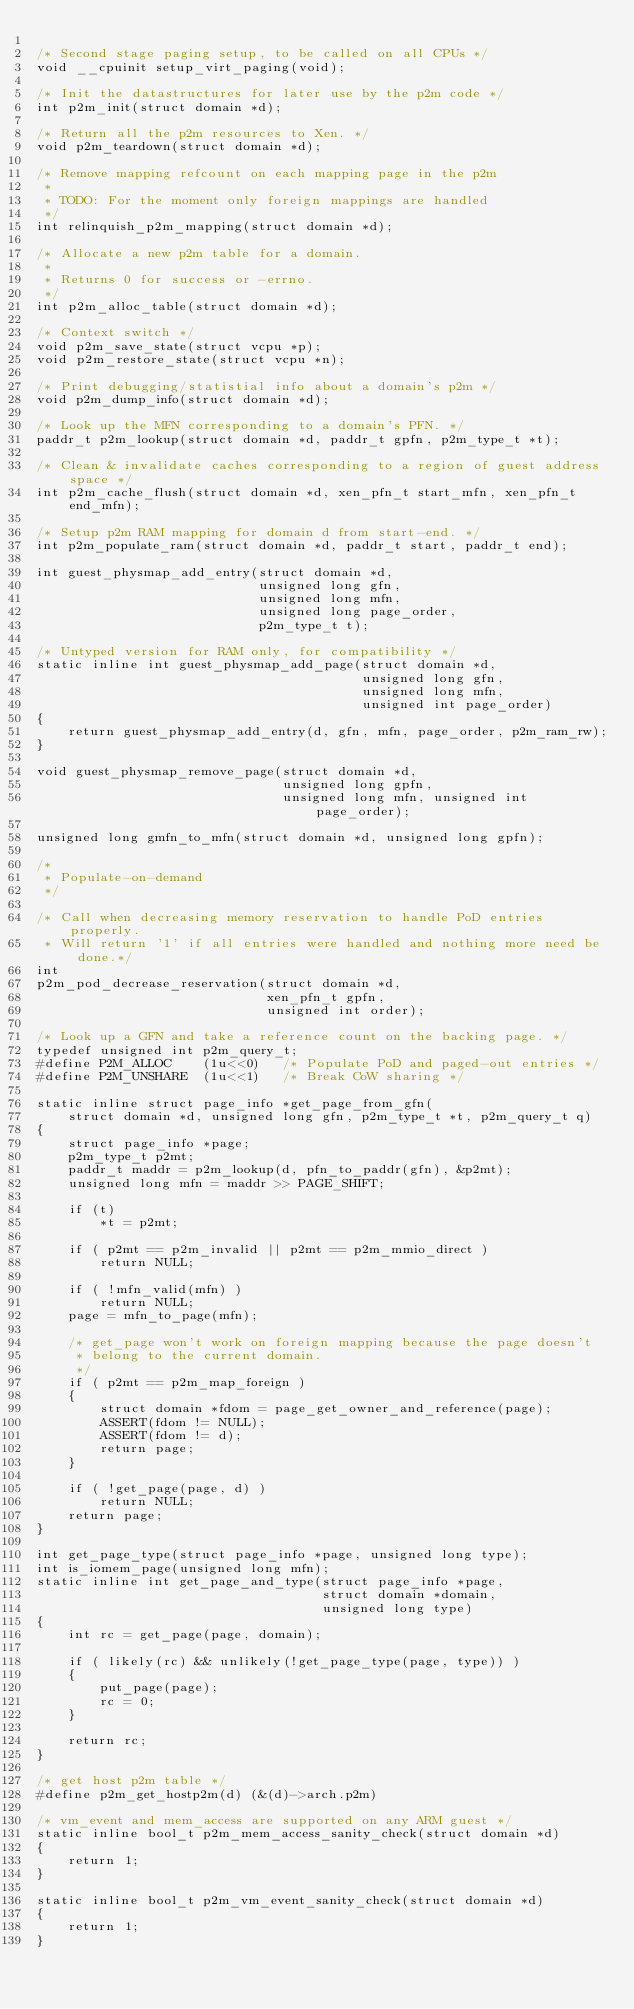<code> <loc_0><loc_0><loc_500><loc_500><_C_>
/* Second stage paging setup, to be called on all CPUs */
void __cpuinit setup_virt_paging(void);

/* Init the datastructures for later use by the p2m code */
int p2m_init(struct domain *d);

/* Return all the p2m resources to Xen. */
void p2m_teardown(struct domain *d);

/* Remove mapping refcount on each mapping page in the p2m
 *
 * TODO: For the moment only foreign mappings are handled
 */
int relinquish_p2m_mapping(struct domain *d);

/* Allocate a new p2m table for a domain.
 *
 * Returns 0 for success or -errno.
 */
int p2m_alloc_table(struct domain *d);

/* Context switch */
void p2m_save_state(struct vcpu *p);
void p2m_restore_state(struct vcpu *n);

/* Print debugging/statistial info about a domain's p2m */
void p2m_dump_info(struct domain *d);

/* Look up the MFN corresponding to a domain's PFN. */
paddr_t p2m_lookup(struct domain *d, paddr_t gpfn, p2m_type_t *t);

/* Clean & invalidate caches corresponding to a region of guest address space */
int p2m_cache_flush(struct domain *d, xen_pfn_t start_mfn, xen_pfn_t end_mfn);

/* Setup p2m RAM mapping for domain d from start-end. */
int p2m_populate_ram(struct domain *d, paddr_t start, paddr_t end);

int guest_physmap_add_entry(struct domain *d,
                            unsigned long gfn,
                            unsigned long mfn,
                            unsigned long page_order,
                            p2m_type_t t);

/* Untyped version for RAM only, for compatibility */
static inline int guest_physmap_add_page(struct domain *d,
                                         unsigned long gfn,
                                         unsigned long mfn,
                                         unsigned int page_order)
{
    return guest_physmap_add_entry(d, gfn, mfn, page_order, p2m_ram_rw);
}

void guest_physmap_remove_page(struct domain *d,
                               unsigned long gpfn,
                               unsigned long mfn, unsigned int page_order);

unsigned long gmfn_to_mfn(struct domain *d, unsigned long gpfn);

/*
 * Populate-on-demand
 */

/* Call when decreasing memory reservation to handle PoD entries properly.
 * Will return '1' if all entries were handled and nothing more need be done.*/
int
p2m_pod_decrease_reservation(struct domain *d,
                             xen_pfn_t gpfn,
                             unsigned int order);

/* Look up a GFN and take a reference count on the backing page. */
typedef unsigned int p2m_query_t;
#define P2M_ALLOC    (1u<<0)   /* Populate PoD and paged-out entries */
#define P2M_UNSHARE  (1u<<1)   /* Break CoW sharing */

static inline struct page_info *get_page_from_gfn(
    struct domain *d, unsigned long gfn, p2m_type_t *t, p2m_query_t q)
{
    struct page_info *page;
    p2m_type_t p2mt;
    paddr_t maddr = p2m_lookup(d, pfn_to_paddr(gfn), &p2mt);
    unsigned long mfn = maddr >> PAGE_SHIFT;

    if (t)
        *t = p2mt;

    if ( p2mt == p2m_invalid || p2mt == p2m_mmio_direct )
        return NULL;

    if ( !mfn_valid(mfn) )
        return NULL;
    page = mfn_to_page(mfn);

    /* get_page won't work on foreign mapping because the page doesn't
     * belong to the current domain.
     */
    if ( p2mt == p2m_map_foreign )
    {
        struct domain *fdom = page_get_owner_and_reference(page);
        ASSERT(fdom != NULL);
        ASSERT(fdom != d);
        return page;
    }

    if ( !get_page(page, d) )
        return NULL;
    return page;
}

int get_page_type(struct page_info *page, unsigned long type);
int is_iomem_page(unsigned long mfn);
static inline int get_page_and_type(struct page_info *page,
                                    struct domain *domain,
                                    unsigned long type)
{
    int rc = get_page(page, domain);

    if ( likely(rc) && unlikely(!get_page_type(page, type)) )
    {
        put_page(page);
        rc = 0;
    }

    return rc;
}

/* get host p2m table */
#define p2m_get_hostp2m(d) (&(d)->arch.p2m)

/* vm_event and mem_access are supported on any ARM guest */
static inline bool_t p2m_mem_access_sanity_check(struct domain *d)
{
    return 1;
}

static inline bool_t p2m_vm_event_sanity_check(struct domain *d)
{
    return 1;
}
</code> 